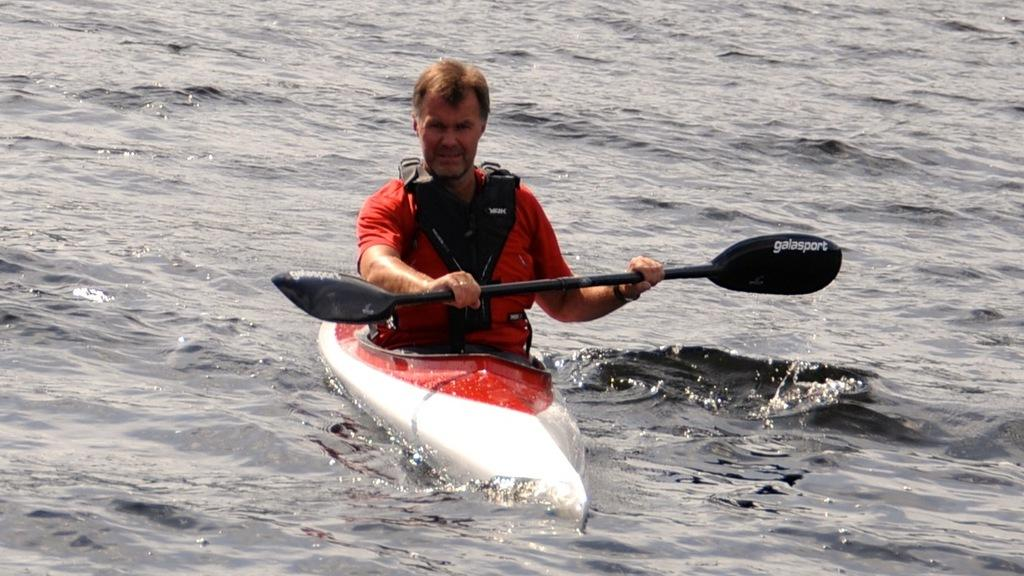Who is present in the image? There is a man in the picture. What is the man holding in the image? The man is holding a paddle. What is the man sitting on in the image? The man is sitting on a boat. Where is the boat located in the image? The boat is on the water. What type of faucet can be seen in the image? There is no faucet present in the image. Is the man wearing a scarf in the image? The provided facts do not mention a scarf, so we cannot determine if the man is wearing one in the image. 